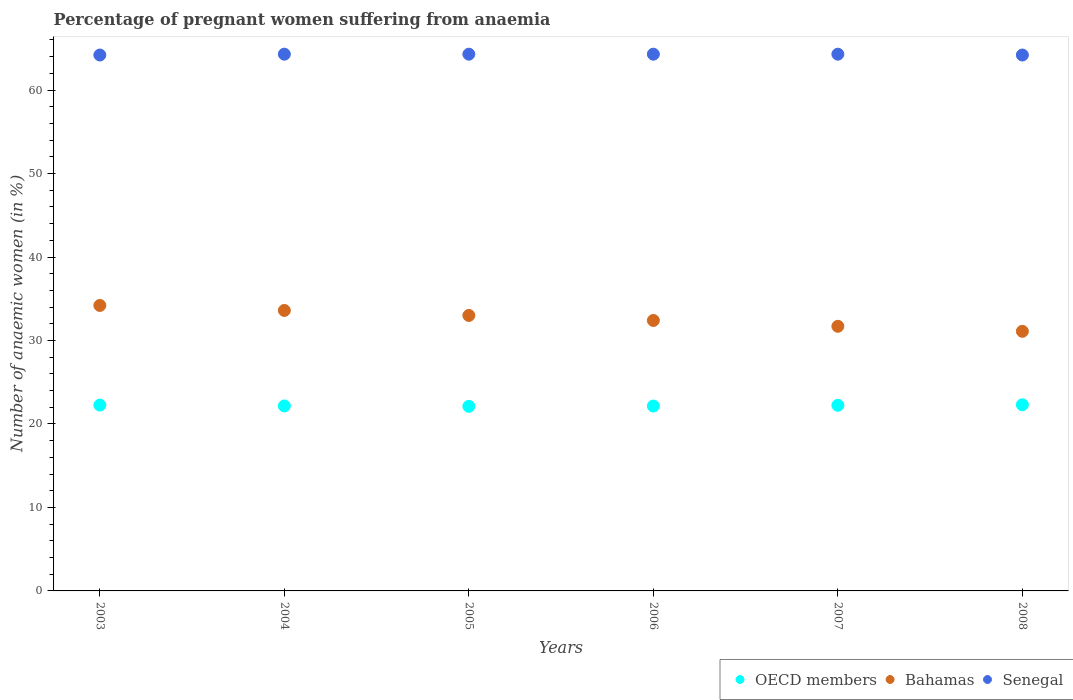Is the number of dotlines equal to the number of legend labels?
Give a very brief answer. Yes. What is the number of anaemic women in Bahamas in 2004?
Provide a succinct answer. 33.6. Across all years, what is the maximum number of anaemic women in OECD members?
Make the answer very short. 22.3. Across all years, what is the minimum number of anaemic women in OECD members?
Make the answer very short. 22.11. In which year was the number of anaemic women in OECD members minimum?
Provide a succinct answer. 2005. What is the total number of anaemic women in Bahamas in the graph?
Give a very brief answer. 196. What is the difference between the number of anaemic women in Senegal in 2007 and that in 2008?
Your response must be concise. 0.1. What is the difference between the number of anaemic women in OECD members in 2003 and the number of anaemic women in Bahamas in 2005?
Give a very brief answer. -10.74. What is the average number of anaemic women in Bahamas per year?
Provide a short and direct response. 32.67. In how many years, is the number of anaemic women in OECD members greater than 44 %?
Provide a short and direct response. 0. What is the ratio of the number of anaemic women in OECD members in 2007 to that in 2008?
Offer a very short reply. 1. Is the number of anaemic women in Bahamas in 2003 less than that in 2007?
Keep it short and to the point. No. Is the difference between the number of anaemic women in Bahamas in 2004 and 2005 greater than the difference between the number of anaemic women in Senegal in 2004 and 2005?
Make the answer very short. Yes. What is the difference between the highest and the second highest number of anaemic women in OECD members?
Make the answer very short. 0.04. What is the difference between the highest and the lowest number of anaemic women in OECD members?
Your answer should be compact. 0.19. In how many years, is the number of anaemic women in OECD members greater than the average number of anaemic women in OECD members taken over all years?
Offer a terse response. 3. Does the number of anaemic women in OECD members monotonically increase over the years?
Ensure brevity in your answer.  No. Is the number of anaemic women in Bahamas strictly greater than the number of anaemic women in Senegal over the years?
Your answer should be very brief. No. Is the number of anaemic women in Bahamas strictly less than the number of anaemic women in OECD members over the years?
Keep it short and to the point. No. How many dotlines are there?
Your answer should be compact. 3. How many years are there in the graph?
Give a very brief answer. 6. What is the difference between two consecutive major ticks on the Y-axis?
Keep it short and to the point. 10. Does the graph contain any zero values?
Provide a succinct answer. No. Does the graph contain grids?
Offer a terse response. No. Where does the legend appear in the graph?
Provide a short and direct response. Bottom right. What is the title of the graph?
Your answer should be compact. Percentage of pregnant women suffering from anaemia. Does "Macao" appear as one of the legend labels in the graph?
Ensure brevity in your answer.  No. What is the label or title of the Y-axis?
Make the answer very short. Number of anaemic women (in %). What is the Number of anaemic women (in %) of OECD members in 2003?
Ensure brevity in your answer.  22.26. What is the Number of anaemic women (in %) in Bahamas in 2003?
Offer a terse response. 34.2. What is the Number of anaemic women (in %) in Senegal in 2003?
Provide a short and direct response. 64.2. What is the Number of anaemic women (in %) in OECD members in 2004?
Your answer should be very brief. 22.16. What is the Number of anaemic women (in %) of Bahamas in 2004?
Your answer should be very brief. 33.6. What is the Number of anaemic women (in %) in Senegal in 2004?
Provide a short and direct response. 64.3. What is the Number of anaemic women (in %) in OECD members in 2005?
Provide a succinct answer. 22.11. What is the Number of anaemic women (in %) in Bahamas in 2005?
Your answer should be very brief. 33. What is the Number of anaemic women (in %) in Senegal in 2005?
Offer a terse response. 64.3. What is the Number of anaemic women (in %) in OECD members in 2006?
Offer a very short reply. 22.15. What is the Number of anaemic women (in %) in Bahamas in 2006?
Provide a succinct answer. 32.4. What is the Number of anaemic women (in %) in Senegal in 2006?
Your answer should be very brief. 64.3. What is the Number of anaemic women (in %) in OECD members in 2007?
Ensure brevity in your answer.  22.24. What is the Number of anaemic women (in %) of Bahamas in 2007?
Make the answer very short. 31.7. What is the Number of anaemic women (in %) in Senegal in 2007?
Ensure brevity in your answer.  64.3. What is the Number of anaemic women (in %) of OECD members in 2008?
Your answer should be compact. 22.3. What is the Number of anaemic women (in %) in Bahamas in 2008?
Offer a terse response. 31.1. What is the Number of anaemic women (in %) of Senegal in 2008?
Give a very brief answer. 64.2. Across all years, what is the maximum Number of anaemic women (in %) in OECD members?
Offer a terse response. 22.3. Across all years, what is the maximum Number of anaemic women (in %) of Bahamas?
Offer a terse response. 34.2. Across all years, what is the maximum Number of anaemic women (in %) of Senegal?
Make the answer very short. 64.3. Across all years, what is the minimum Number of anaemic women (in %) in OECD members?
Your response must be concise. 22.11. Across all years, what is the minimum Number of anaemic women (in %) of Bahamas?
Ensure brevity in your answer.  31.1. Across all years, what is the minimum Number of anaemic women (in %) of Senegal?
Ensure brevity in your answer.  64.2. What is the total Number of anaemic women (in %) in OECD members in the graph?
Provide a short and direct response. 133.23. What is the total Number of anaemic women (in %) of Bahamas in the graph?
Offer a very short reply. 196. What is the total Number of anaemic women (in %) in Senegal in the graph?
Your response must be concise. 385.6. What is the difference between the Number of anaemic women (in %) of OECD members in 2003 and that in 2004?
Make the answer very short. 0.1. What is the difference between the Number of anaemic women (in %) in Senegal in 2003 and that in 2004?
Provide a short and direct response. -0.1. What is the difference between the Number of anaemic women (in %) of OECD members in 2003 and that in 2005?
Offer a terse response. 0.15. What is the difference between the Number of anaemic women (in %) in OECD members in 2003 and that in 2006?
Provide a succinct answer. 0.12. What is the difference between the Number of anaemic women (in %) in Bahamas in 2003 and that in 2006?
Keep it short and to the point. 1.8. What is the difference between the Number of anaemic women (in %) in OECD members in 2003 and that in 2007?
Give a very brief answer. 0.03. What is the difference between the Number of anaemic women (in %) of Bahamas in 2003 and that in 2007?
Ensure brevity in your answer.  2.5. What is the difference between the Number of anaemic women (in %) of Senegal in 2003 and that in 2007?
Make the answer very short. -0.1. What is the difference between the Number of anaemic women (in %) of OECD members in 2003 and that in 2008?
Keep it short and to the point. -0.04. What is the difference between the Number of anaemic women (in %) of OECD members in 2004 and that in 2005?
Keep it short and to the point. 0.05. What is the difference between the Number of anaemic women (in %) of Bahamas in 2004 and that in 2005?
Give a very brief answer. 0.6. What is the difference between the Number of anaemic women (in %) of OECD members in 2004 and that in 2006?
Provide a succinct answer. 0.01. What is the difference between the Number of anaemic women (in %) in OECD members in 2004 and that in 2007?
Make the answer very short. -0.08. What is the difference between the Number of anaemic women (in %) of Senegal in 2004 and that in 2007?
Provide a succinct answer. 0. What is the difference between the Number of anaemic women (in %) of OECD members in 2004 and that in 2008?
Ensure brevity in your answer.  -0.14. What is the difference between the Number of anaemic women (in %) of OECD members in 2005 and that in 2006?
Your response must be concise. -0.03. What is the difference between the Number of anaemic women (in %) of Bahamas in 2005 and that in 2006?
Your answer should be very brief. 0.6. What is the difference between the Number of anaemic women (in %) of OECD members in 2005 and that in 2007?
Keep it short and to the point. -0.12. What is the difference between the Number of anaemic women (in %) in Bahamas in 2005 and that in 2007?
Offer a very short reply. 1.3. What is the difference between the Number of anaemic women (in %) of Senegal in 2005 and that in 2007?
Provide a succinct answer. 0. What is the difference between the Number of anaemic women (in %) in OECD members in 2005 and that in 2008?
Make the answer very short. -0.19. What is the difference between the Number of anaemic women (in %) in Bahamas in 2005 and that in 2008?
Ensure brevity in your answer.  1.9. What is the difference between the Number of anaemic women (in %) in Senegal in 2005 and that in 2008?
Make the answer very short. 0.1. What is the difference between the Number of anaemic women (in %) of OECD members in 2006 and that in 2007?
Make the answer very short. -0.09. What is the difference between the Number of anaemic women (in %) in Senegal in 2006 and that in 2007?
Your answer should be compact. 0. What is the difference between the Number of anaemic women (in %) in OECD members in 2006 and that in 2008?
Give a very brief answer. -0.15. What is the difference between the Number of anaemic women (in %) in OECD members in 2007 and that in 2008?
Offer a terse response. -0.06. What is the difference between the Number of anaemic women (in %) in Senegal in 2007 and that in 2008?
Your response must be concise. 0.1. What is the difference between the Number of anaemic women (in %) of OECD members in 2003 and the Number of anaemic women (in %) of Bahamas in 2004?
Provide a succinct answer. -11.34. What is the difference between the Number of anaemic women (in %) of OECD members in 2003 and the Number of anaemic women (in %) of Senegal in 2004?
Your answer should be very brief. -42.04. What is the difference between the Number of anaemic women (in %) in Bahamas in 2003 and the Number of anaemic women (in %) in Senegal in 2004?
Your answer should be compact. -30.1. What is the difference between the Number of anaemic women (in %) of OECD members in 2003 and the Number of anaemic women (in %) of Bahamas in 2005?
Your answer should be very brief. -10.74. What is the difference between the Number of anaemic women (in %) in OECD members in 2003 and the Number of anaemic women (in %) in Senegal in 2005?
Make the answer very short. -42.04. What is the difference between the Number of anaemic women (in %) in Bahamas in 2003 and the Number of anaemic women (in %) in Senegal in 2005?
Provide a succinct answer. -30.1. What is the difference between the Number of anaemic women (in %) of OECD members in 2003 and the Number of anaemic women (in %) of Bahamas in 2006?
Give a very brief answer. -10.14. What is the difference between the Number of anaemic women (in %) in OECD members in 2003 and the Number of anaemic women (in %) in Senegal in 2006?
Offer a terse response. -42.04. What is the difference between the Number of anaemic women (in %) in Bahamas in 2003 and the Number of anaemic women (in %) in Senegal in 2006?
Make the answer very short. -30.1. What is the difference between the Number of anaemic women (in %) in OECD members in 2003 and the Number of anaemic women (in %) in Bahamas in 2007?
Keep it short and to the point. -9.44. What is the difference between the Number of anaemic women (in %) in OECD members in 2003 and the Number of anaemic women (in %) in Senegal in 2007?
Offer a very short reply. -42.04. What is the difference between the Number of anaemic women (in %) in Bahamas in 2003 and the Number of anaemic women (in %) in Senegal in 2007?
Provide a short and direct response. -30.1. What is the difference between the Number of anaemic women (in %) of OECD members in 2003 and the Number of anaemic women (in %) of Bahamas in 2008?
Provide a succinct answer. -8.84. What is the difference between the Number of anaemic women (in %) in OECD members in 2003 and the Number of anaemic women (in %) in Senegal in 2008?
Keep it short and to the point. -41.94. What is the difference between the Number of anaemic women (in %) of Bahamas in 2003 and the Number of anaemic women (in %) of Senegal in 2008?
Ensure brevity in your answer.  -30. What is the difference between the Number of anaemic women (in %) in OECD members in 2004 and the Number of anaemic women (in %) in Bahamas in 2005?
Your answer should be very brief. -10.84. What is the difference between the Number of anaemic women (in %) in OECD members in 2004 and the Number of anaemic women (in %) in Senegal in 2005?
Offer a terse response. -42.14. What is the difference between the Number of anaemic women (in %) of Bahamas in 2004 and the Number of anaemic women (in %) of Senegal in 2005?
Offer a terse response. -30.7. What is the difference between the Number of anaemic women (in %) in OECD members in 2004 and the Number of anaemic women (in %) in Bahamas in 2006?
Ensure brevity in your answer.  -10.24. What is the difference between the Number of anaemic women (in %) of OECD members in 2004 and the Number of anaemic women (in %) of Senegal in 2006?
Your answer should be compact. -42.14. What is the difference between the Number of anaemic women (in %) in Bahamas in 2004 and the Number of anaemic women (in %) in Senegal in 2006?
Ensure brevity in your answer.  -30.7. What is the difference between the Number of anaemic women (in %) of OECD members in 2004 and the Number of anaemic women (in %) of Bahamas in 2007?
Your answer should be compact. -9.54. What is the difference between the Number of anaemic women (in %) in OECD members in 2004 and the Number of anaemic women (in %) in Senegal in 2007?
Provide a succinct answer. -42.14. What is the difference between the Number of anaemic women (in %) of Bahamas in 2004 and the Number of anaemic women (in %) of Senegal in 2007?
Provide a succinct answer. -30.7. What is the difference between the Number of anaemic women (in %) of OECD members in 2004 and the Number of anaemic women (in %) of Bahamas in 2008?
Ensure brevity in your answer.  -8.94. What is the difference between the Number of anaemic women (in %) of OECD members in 2004 and the Number of anaemic women (in %) of Senegal in 2008?
Keep it short and to the point. -42.04. What is the difference between the Number of anaemic women (in %) of Bahamas in 2004 and the Number of anaemic women (in %) of Senegal in 2008?
Offer a very short reply. -30.6. What is the difference between the Number of anaemic women (in %) of OECD members in 2005 and the Number of anaemic women (in %) of Bahamas in 2006?
Your answer should be very brief. -10.29. What is the difference between the Number of anaemic women (in %) of OECD members in 2005 and the Number of anaemic women (in %) of Senegal in 2006?
Ensure brevity in your answer.  -42.19. What is the difference between the Number of anaemic women (in %) of Bahamas in 2005 and the Number of anaemic women (in %) of Senegal in 2006?
Keep it short and to the point. -31.3. What is the difference between the Number of anaemic women (in %) in OECD members in 2005 and the Number of anaemic women (in %) in Bahamas in 2007?
Your answer should be compact. -9.59. What is the difference between the Number of anaemic women (in %) in OECD members in 2005 and the Number of anaemic women (in %) in Senegal in 2007?
Give a very brief answer. -42.19. What is the difference between the Number of anaemic women (in %) in Bahamas in 2005 and the Number of anaemic women (in %) in Senegal in 2007?
Offer a very short reply. -31.3. What is the difference between the Number of anaemic women (in %) in OECD members in 2005 and the Number of anaemic women (in %) in Bahamas in 2008?
Provide a short and direct response. -8.99. What is the difference between the Number of anaemic women (in %) of OECD members in 2005 and the Number of anaemic women (in %) of Senegal in 2008?
Your response must be concise. -42.09. What is the difference between the Number of anaemic women (in %) of Bahamas in 2005 and the Number of anaemic women (in %) of Senegal in 2008?
Offer a very short reply. -31.2. What is the difference between the Number of anaemic women (in %) of OECD members in 2006 and the Number of anaemic women (in %) of Bahamas in 2007?
Your answer should be compact. -9.55. What is the difference between the Number of anaemic women (in %) in OECD members in 2006 and the Number of anaemic women (in %) in Senegal in 2007?
Ensure brevity in your answer.  -42.15. What is the difference between the Number of anaemic women (in %) of Bahamas in 2006 and the Number of anaemic women (in %) of Senegal in 2007?
Give a very brief answer. -31.9. What is the difference between the Number of anaemic women (in %) of OECD members in 2006 and the Number of anaemic women (in %) of Bahamas in 2008?
Provide a succinct answer. -8.95. What is the difference between the Number of anaemic women (in %) of OECD members in 2006 and the Number of anaemic women (in %) of Senegal in 2008?
Provide a short and direct response. -42.05. What is the difference between the Number of anaemic women (in %) of Bahamas in 2006 and the Number of anaemic women (in %) of Senegal in 2008?
Keep it short and to the point. -31.8. What is the difference between the Number of anaemic women (in %) of OECD members in 2007 and the Number of anaemic women (in %) of Bahamas in 2008?
Provide a short and direct response. -8.86. What is the difference between the Number of anaemic women (in %) of OECD members in 2007 and the Number of anaemic women (in %) of Senegal in 2008?
Provide a short and direct response. -41.96. What is the difference between the Number of anaemic women (in %) in Bahamas in 2007 and the Number of anaemic women (in %) in Senegal in 2008?
Your answer should be compact. -32.5. What is the average Number of anaemic women (in %) of OECD members per year?
Provide a short and direct response. 22.2. What is the average Number of anaemic women (in %) in Bahamas per year?
Ensure brevity in your answer.  32.67. What is the average Number of anaemic women (in %) of Senegal per year?
Provide a succinct answer. 64.27. In the year 2003, what is the difference between the Number of anaemic women (in %) of OECD members and Number of anaemic women (in %) of Bahamas?
Offer a terse response. -11.94. In the year 2003, what is the difference between the Number of anaemic women (in %) of OECD members and Number of anaemic women (in %) of Senegal?
Provide a succinct answer. -41.94. In the year 2003, what is the difference between the Number of anaemic women (in %) in Bahamas and Number of anaemic women (in %) in Senegal?
Offer a terse response. -30. In the year 2004, what is the difference between the Number of anaemic women (in %) of OECD members and Number of anaemic women (in %) of Bahamas?
Your response must be concise. -11.44. In the year 2004, what is the difference between the Number of anaemic women (in %) of OECD members and Number of anaemic women (in %) of Senegal?
Keep it short and to the point. -42.14. In the year 2004, what is the difference between the Number of anaemic women (in %) of Bahamas and Number of anaemic women (in %) of Senegal?
Your answer should be compact. -30.7. In the year 2005, what is the difference between the Number of anaemic women (in %) of OECD members and Number of anaemic women (in %) of Bahamas?
Make the answer very short. -10.89. In the year 2005, what is the difference between the Number of anaemic women (in %) of OECD members and Number of anaemic women (in %) of Senegal?
Make the answer very short. -42.19. In the year 2005, what is the difference between the Number of anaemic women (in %) of Bahamas and Number of anaemic women (in %) of Senegal?
Keep it short and to the point. -31.3. In the year 2006, what is the difference between the Number of anaemic women (in %) of OECD members and Number of anaemic women (in %) of Bahamas?
Give a very brief answer. -10.25. In the year 2006, what is the difference between the Number of anaemic women (in %) in OECD members and Number of anaemic women (in %) in Senegal?
Give a very brief answer. -42.15. In the year 2006, what is the difference between the Number of anaemic women (in %) of Bahamas and Number of anaemic women (in %) of Senegal?
Give a very brief answer. -31.9. In the year 2007, what is the difference between the Number of anaemic women (in %) in OECD members and Number of anaemic women (in %) in Bahamas?
Keep it short and to the point. -9.46. In the year 2007, what is the difference between the Number of anaemic women (in %) in OECD members and Number of anaemic women (in %) in Senegal?
Offer a terse response. -42.06. In the year 2007, what is the difference between the Number of anaemic women (in %) in Bahamas and Number of anaemic women (in %) in Senegal?
Provide a succinct answer. -32.6. In the year 2008, what is the difference between the Number of anaemic women (in %) of OECD members and Number of anaemic women (in %) of Bahamas?
Keep it short and to the point. -8.8. In the year 2008, what is the difference between the Number of anaemic women (in %) of OECD members and Number of anaemic women (in %) of Senegal?
Your answer should be very brief. -41.9. In the year 2008, what is the difference between the Number of anaemic women (in %) in Bahamas and Number of anaemic women (in %) in Senegal?
Offer a very short reply. -33.1. What is the ratio of the Number of anaemic women (in %) in Bahamas in 2003 to that in 2004?
Give a very brief answer. 1.02. What is the ratio of the Number of anaemic women (in %) in Senegal in 2003 to that in 2004?
Give a very brief answer. 1. What is the ratio of the Number of anaemic women (in %) in OECD members in 2003 to that in 2005?
Provide a short and direct response. 1.01. What is the ratio of the Number of anaemic women (in %) in Bahamas in 2003 to that in 2005?
Offer a terse response. 1.04. What is the ratio of the Number of anaemic women (in %) in Senegal in 2003 to that in 2005?
Offer a terse response. 1. What is the ratio of the Number of anaemic women (in %) in Bahamas in 2003 to that in 2006?
Your answer should be very brief. 1.06. What is the ratio of the Number of anaemic women (in %) in OECD members in 2003 to that in 2007?
Your response must be concise. 1. What is the ratio of the Number of anaemic women (in %) in Bahamas in 2003 to that in 2007?
Give a very brief answer. 1.08. What is the ratio of the Number of anaemic women (in %) of Senegal in 2003 to that in 2007?
Your answer should be compact. 1. What is the ratio of the Number of anaemic women (in %) of Bahamas in 2003 to that in 2008?
Give a very brief answer. 1.1. What is the ratio of the Number of anaemic women (in %) of OECD members in 2004 to that in 2005?
Offer a terse response. 1. What is the ratio of the Number of anaemic women (in %) of Bahamas in 2004 to that in 2005?
Provide a succinct answer. 1.02. What is the ratio of the Number of anaemic women (in %) of Bahamas in 2004 to that in 2006?
Your answer should be compact. 1.04. What is the ratio of the Number of anaemic women (in %) in OECD members in 2004 to that in 2007?
Offer a very short reply. 1. What is the ratio of the Number of anaemic women (in %) in Bahamas in 2004 to that in 2007?
Make the answer very short. 1.06. What is the ratio of the Number of anaemic women (in %) of OECD members in 2004 to that in 2008?
Offer a terse response. 0.99. What is the ratio of the Number of anaemic women (in %) in Bahamas in 2004 to that in 2008?
Ensure brevity in your answer.  1.08. What is the ratio of the Number of anaemic women (in %) in Senegal in 2004 to that in 2008?
Keep it short and to the point. 1. What is the ratio of the Number of anaemic women (in %) in Bahamas in 2005 to that in 2006?
Give a very brief answer. 1.02. What is the ratio of the Number of anaemic women (in %) in OECD members in 2005 to that in 2007?
Make the answer very short. 0.99. What is the ratio of the Number of anaemic women (in %) in Bahamas in 2005 to that in 2007?
Provide a succinct answer. 1.04. What is the ratio of the Number of anaemic women (in %) of OECD members in 2005 to that in 2008?
Keep it short and to the point. 0.99. What is the ratio of the Number of anaemic women (in %) in Bahamas in 2005 to that in 2008?
Offer a very short reply. 1.06. What is the ratio of the Number of anaemic women (in %) in OECD members in 2006 to that in 2007?
Your answer should be very brief. 1. What is the ratio of the Number of anaemic women (in %) in Bahamas in 2006 to that in 2007?
Keep it short and to the point. 1.02. What is the ratio of the Number of anaemic women (in %) in Senegal in 2006 to that in 2007?
Ensure brevity in your answer.  1. What is the ratio of the Number of anaemic women (in %) of Bahamas in 2006 to that in 2008?
Ensure brevity in your answer.  1.04. What is the ratio of the Number of anaemic women (in %) in Senegal in 2006 to that in 2008?
Offer a very short reply. 1. What is the ratio of the Number of anaemic women (in %) of Bahamas in 2007 to that in 2008?
Your response must be concise. 1.02. What is the ratio of the Number of anaemic women (in %) of Senegal in 2007 to that in 2008?
Offer a very short reply. 1. What is the difference between the highest and the second highest Number of anaemic women (in %) of OECD members?
Your answer should be compact. 0.04. What is the difference between the highest and the second highest Number of anaemic women (in %) in Bahamas?
Make the answer very short. 0.6. What is the difference between the highest and the lowest Number of anaemic women (in %) in OECD members?
Your answer should be very brief. 0.19. What is the difference between the highest and the lowest Number of anaemic women (in %) of Bahamas?
Your answer should be very brief. 3.1. 